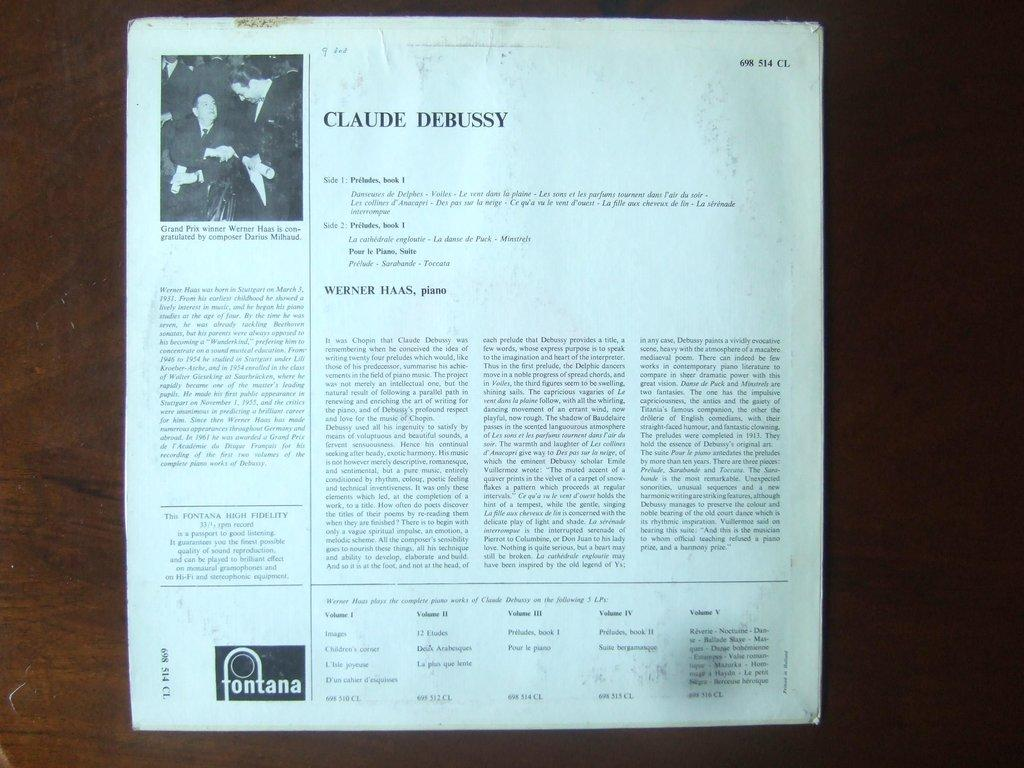Provide a one-sentence caption for the provided image. The back of an album cover provides details on Claude Debussy. 